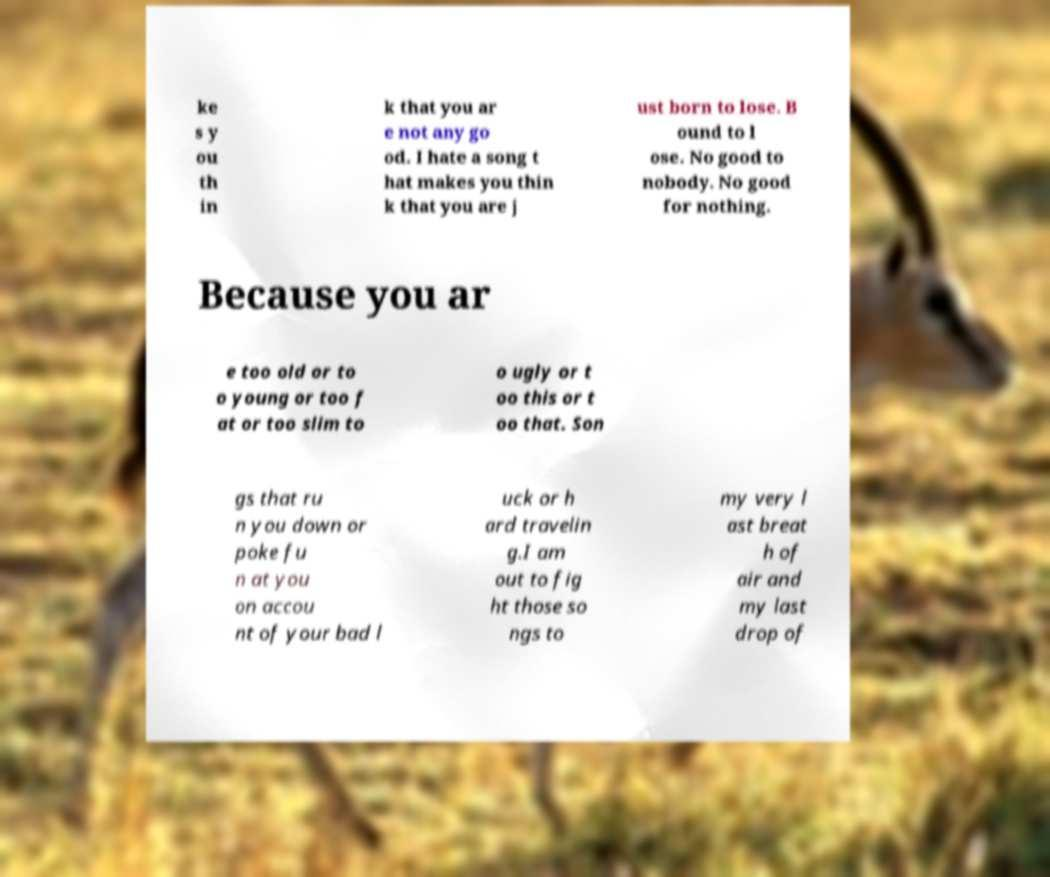Please read and relay the text visible in this image. What does it say? ke s y ou th in k that you ar e not any go od. I hate a song t hat makes you thin k that you are j ust born to lose. B ound to l ose. No good to nobody. No good for nothing. Because you ar e too old or to o young or too f at or too slim to o ugly or t oo this or t oo that. Son gs that ru n you down or poke fu n at you on accou nt of your bad l uck or h ard travelin g.I am out to fig ht those so ngs to my very l ast breat h of air and my last drop of 